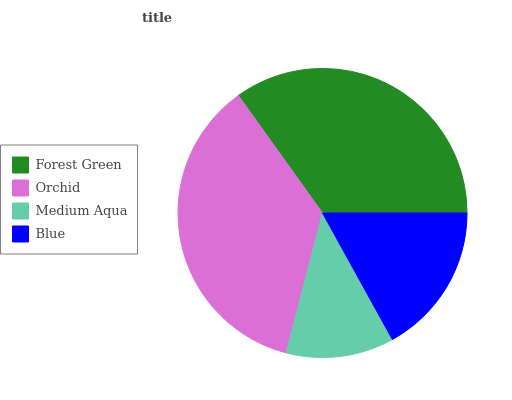Is Medium Aqua the minimum?
Answer yes or no. Yes. Is Orchid the maximum?
Answer yes or no. Yes. Is Orchid the minimum?
Answer yes or no. No. Is Medium Aqua the maximum?
Answer yes or no. No. Is Orchid greater than Medium Aqua?
Answer yes or no. Yes. Is Medium Aqua less than Orchid?
Answer yes or no. Yes. Is Medium Aqua greater than Orchid?
Answer yes or no. No. Is Orchid less than Medium Aqua?
Answer yes or no. No. Is Forest Green the high median?
Answer yes or no. Yes. Is Blue the low median?
Answer yes or no. Yes. Is Medium Aqua the high median?
Answer yes or no. No. Is Orchid the low median?
Answer yes or no. No. 